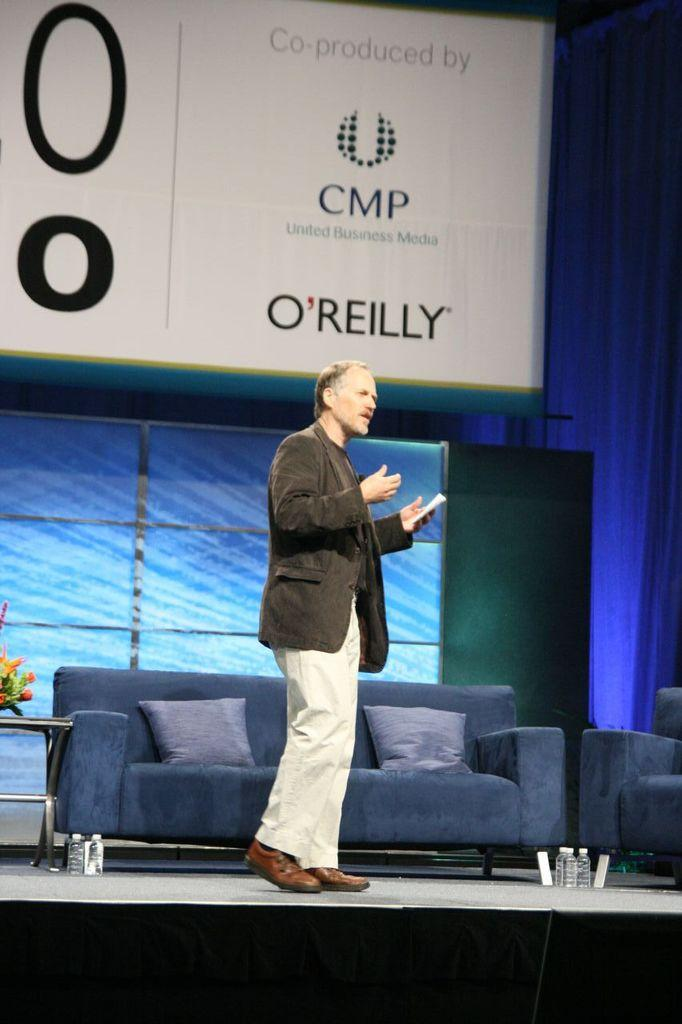What is hanging or displayed in the image? There is a banner in the image. Who or what can be seen in the image besides the banner? There is a man standing in the image. What type of furniture is present in the image? There is a sofa in the image. What can be seen on the sofa in the image? There are pillows in the image. How many cents are visible on the banner in the image? There are no cents displayed on the banner in the image. 